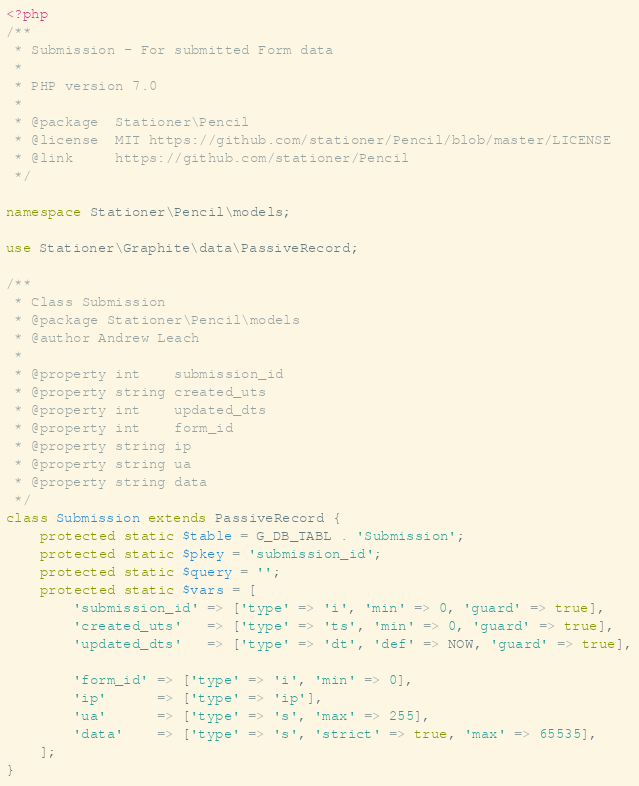<code> <loc_0><loc_0><loc_500><loc_500><_PHP_><?php
/**
 * Submission - For submitted Form data
 *
 * PHP version 7.0
 *
 * @package  Stationer\Pencil
 * @license  MIT https://github.com/stationer/Pencil/blob/master/LICENSE
 * @link     https://github.com/stationer/Pencil
 */

namespace Stationer\Pencil\models;

use Stationer\Graphite\data\PassiveRecord;

/**
 * Class Submission
 * @package Stationer\Pencil\models
 * @author Andrew Leach
 *
 * @property int    submission_id
 * @property string created_uts
 * @property int    updated_dts
 * @property int    form_id
 * @property string ip
 * @property string ua
 * @property string data
 */
class Submission extends PassiveRecord {
    protected static $table = G_DB_TABL . 'Submission';
    protected static $pkey = 'submission_id';
    protected static $query = '';
    protected static $vars = [
        'submission_id' => ['type' => 'i', 'min' => 0, 'guard' => true],
        'created_uts'   => ['type' => 'ts', 'min' => 0, 'guard' => true],
        'updated_dts'   => ['type' => 'dt', 'def' => NOW, 'guard' => true],

        'form_id' => ['type' => 'i', 'min' => 0],
        'ip'      => ['type' => 'ip'],
        'ua'      => ['type' => 's', 'max' => 255],
        'data'    => ['type' => 's', 'strict' => true, 'max' => 65535],
    ];
}
</code> 